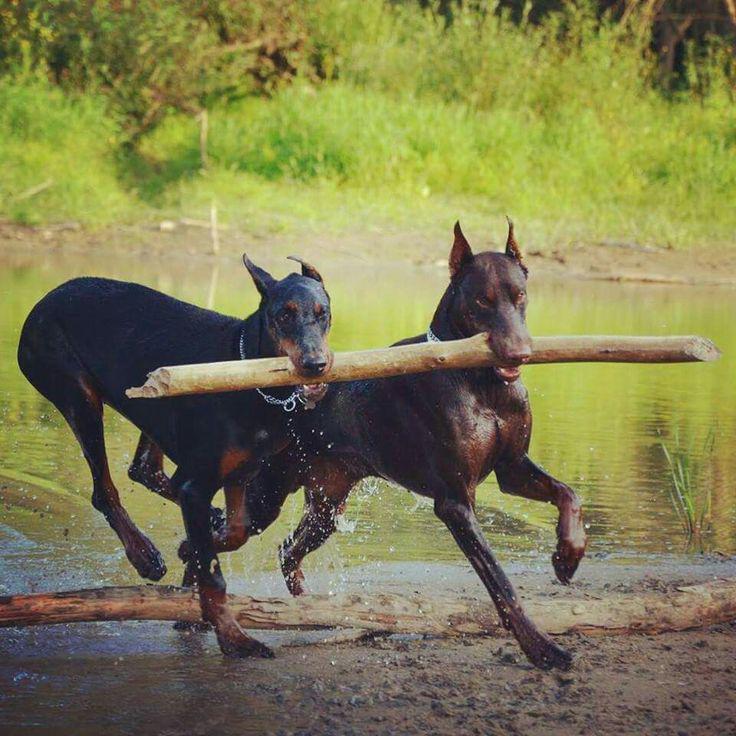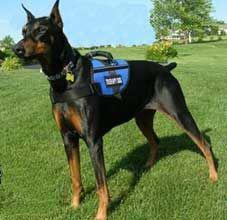The first image is the image on the left, the second image is the image on the right. Given the left and right images, does the statement "A black dog is facing left while wearing a harness." hold true? Answer yes or no. Yes. The first image is the image on the left, the second image is the image on the right. Given the left and right images, does the statement "One image contains one left-facing doberman with pointy ears and docked tail standing in profile and wearing a vest-type harness." hold true? Answer yes or no. Yes. 